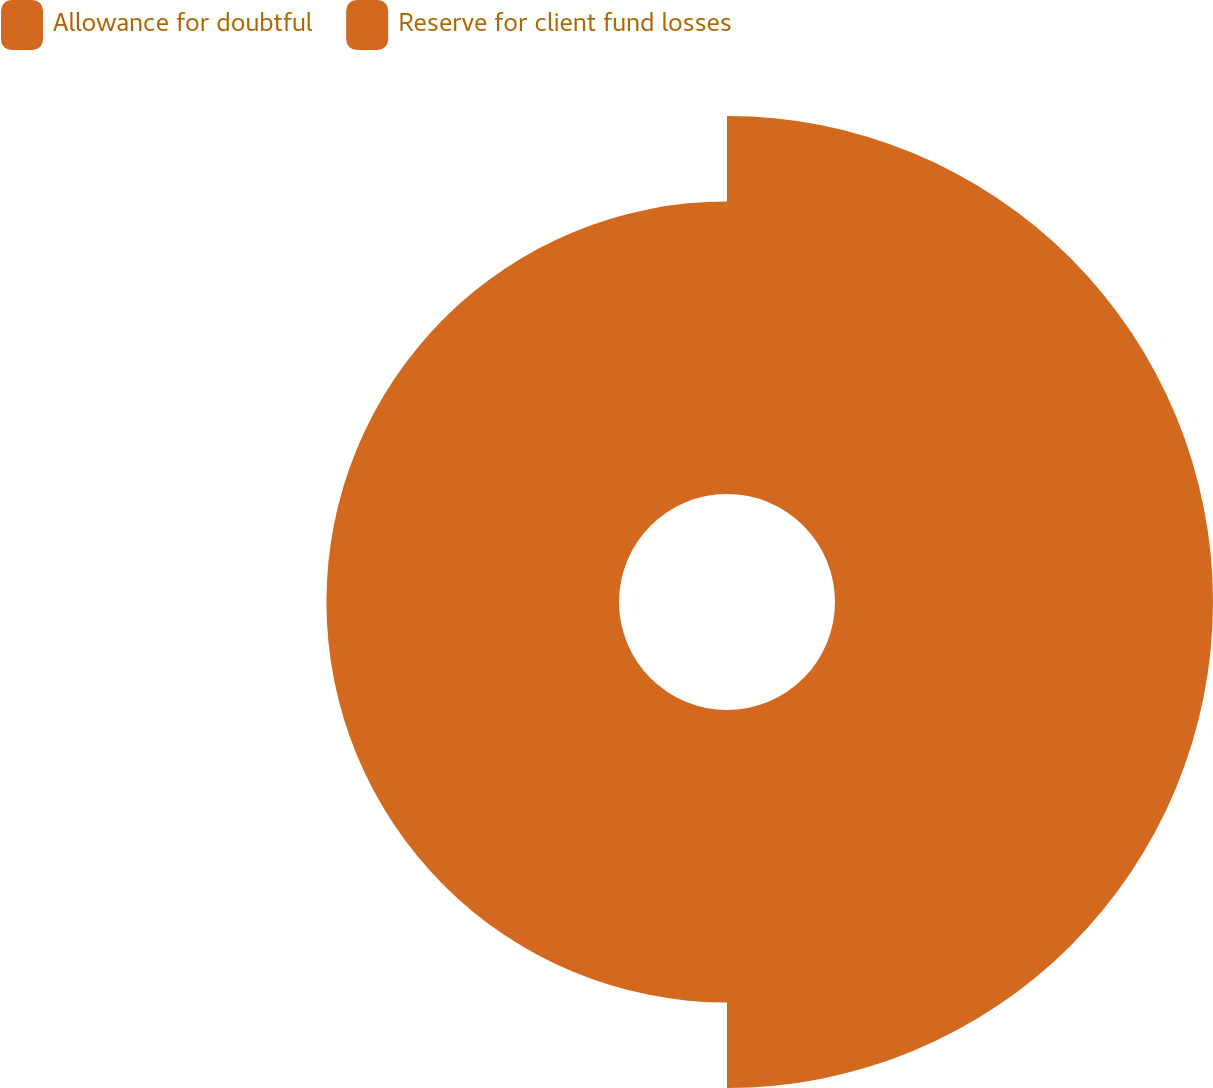<chart> <loc_0><loc_0><loc_500><loc_500><pie_chart><fcel>Allowance for doubtful<fcel>Reserve for client fund losses<nl><fcel>56.37%<fcel>43.63%<nl></chart> 